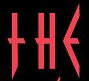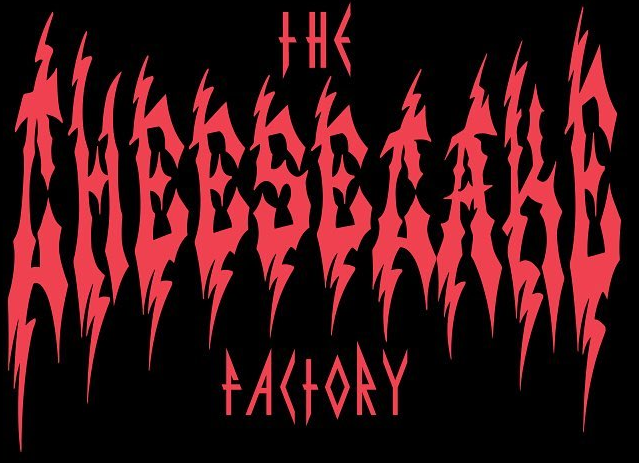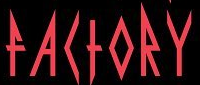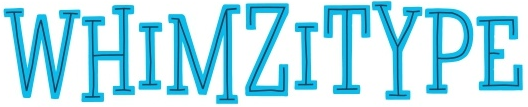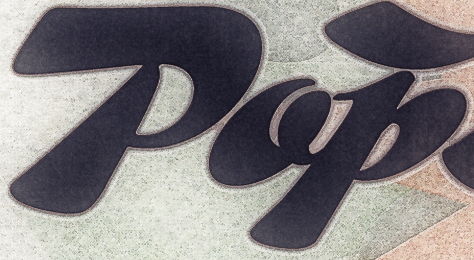What text is displayed in these images sequentially, separated by a semicolon? THE; CHEESECAKE; FACTORY; WHIMZITYPE; Pop 